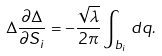<formula> <loc_0><loc_0><loc_500><loc_500>\Delta \frac { \partial \Delta } { \partial S _ { i } } = - \frac { \sqrt { \lambda } } { 2 \pi } \int _ { b _ { i } } \, d q .</formula> 